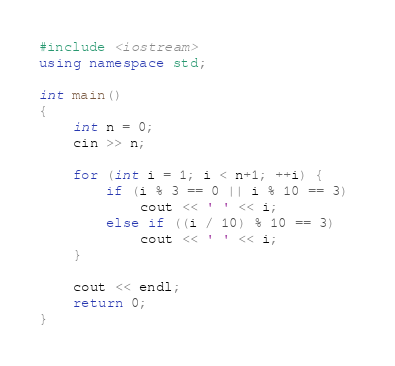<code> <loc_0><loc_0><loc_500><loc_500><_C++_>#include <iostream>
using namespace std;

int main()
{
	int n = 0;
	cin >> n;

	for (int i = 1; i < n+1; ++i) {
		if (i % 3 == 0 || i % 10 == 3) 
			cout << ' ' << i;
		else if ((i / 10) % 10 == 3) 
			cout << ' ' << i;
	}

	cout << endl;
	return 0;
}</code> 